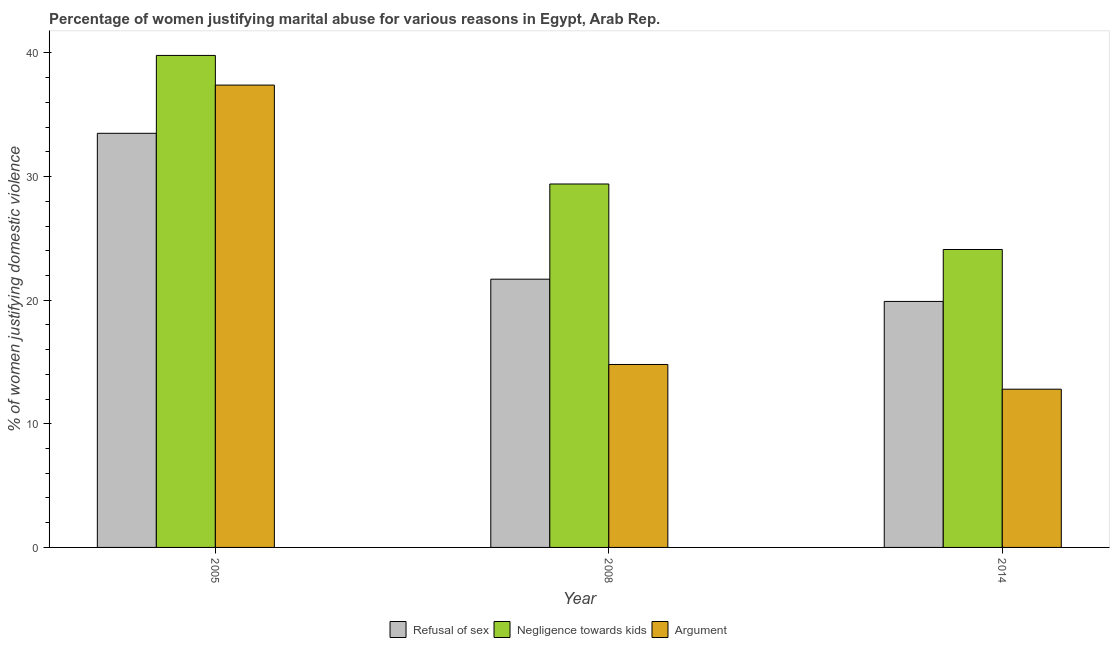How many different coloured bars are there?
Keep it short and to the point. 3. How many groups of bars are there?
Provide a short and direct response. 3. Are the number of bars on each tick of the X-axis equal?
Provide a short and direct response. Yes. What is the percentage of women justifying domestic violence due to arguments in 2005?
Your answer should be compact. 37.4. Across all years, what is the maximum percentage of women justifying domestic violence due to negligence towards kids?
Make the answer very short. 39.8. What is the total percentage of women justifying domestic violence due to arguments in the graph?
Your answer should be very brief. 65. What is the difference between the percentage of women justifying domestic violence due to negligence towards kids in 2014 and the percentage of women justifying domestic violence due to refusal of sex in 2008?
Provide a succinct answer. -5.3. What is the average percentage of women justifying domestic violence due to negligence towards kids per year?
Your response must be concise. 31.1. In how many years, is the percentage of women justifying domestic violence due to negligence towards kids greater than 34 %?
Provide a short and direct response. 1. What is the ratio of the percentage of women justifying domestic violence due to negligence towards kids in 2005 to that in 2014?
Your answer should be very brief. 1.65. Is the percentage of women justifying domestic violence due to arguments in 2008 less than that in 2014?
Ensure brevity in your answer.  No. Is the difference between the percentage of women justifying domestic violence due to arguments in 2008 and 2014 greater than the difference between the percentage of women justifying domestic violence due to refusal of sex in 2008 and 2014?
Offer a terse response. No. What is the difference between the highest and the second highest percentage of women justifying domestic violence due to arguments?
Your response must be concise. 22.6. What is the difference between the highest and the lowest percentage of women justifying domestic violence due to arguments?
Your answer should be compact. 24.6. In how many years, is the percentage of women justifying domestic violence due to refusal of sex greater than the average percentage of women justifying domestic violence due to refusal of sex taken over all years?
Ensure brevity in your answer.  1. Is the sum of the percentage of women justifying domestic violence due to arguments in 2005 and 2014 greater than the maximum percentage of women justifying domestic violence due to refusal of sex across all years?
Offer a very short reply. Yes. What does the 2nd bar from the left in 2005 represents?
Ensure brevity in your answer.  Negligence towards kids. What does the 3rd bar from the right in 2008 represents?
Keep it short and to the point. Refusal of sex. How many bars are there?
Make the answer very short. 9. Are all the bars in the graph horizontal?
Make the answer very short. No. How many years are there in the graph?
Ensure brevity in your answer.  3. Does the graph contain grids?
Provide a short and direct response. No. Where does the legend appear in the graph?
Your answer should be compact. Bottom center. How are the legend labels stacked?
Ensure brevity in your answer.  Horizontal. What is the title of the graph?
Ensure brevity in your answer.  Percentage of women justifying marital abuse for various reasons in Egypt, Arab Rep. Does "Manufactures" appear as one of the legend labels in the graph?
Offer a terse response. No. What is the label or title of the X-axis?
Your response must be concise. Year. What is the label or title of the Y-axis?
Give a very brief answer. % of women justifying domestic violence. What is the % of women justifying domestic violence of Refusal of sex in 2005?
Keep it short and to the point. 33.5. What is the % of women justifying domestic violence of Negligence towards kids in 2005?
Offer a terse response. 39.8. What is the % of women justifying domestic violence of Argument in 2005?
Make the answer very short. 37.4. What is the % of women justifying domestic violence of Refusal of sex in 2008?
Your answer should be very brief. 21.7. What is the % of women justifying domestic violence in Negligence towards kids in 2008?
Keep it short and to the point. 29.4. What is the % of women justifying domestic violence in Refusal of sex in 2014?
Offer a very short reply. 19.9. What is the % of women justifying domestic violence in Negligence towards kids in 2014?
Ensure brevity in your answer.  24.1. What is the % of women justifying domestic violence of Argument in 2014?
Ensure brevity in your answer.  12.8. Across all years, what is the maximum % of women justifying domestic violence of Refusal of sex?
Provide a short and direct response. 33.5. Across all years, what is the maximum % of women justifying domestic violence in Negligence towards kids?
Offer a very short reply. 39.8. Across all years, what is the maximum % of women justifying domestic violence in Argument?
Your answer should be very brief. 37.4. Across all years, what is the minimum % of women justifying domestic violence in Negligence towards kids?
Offer a terse response. 24.1. Across all years, what is the minimum % of women justifying domestic violence of Argument?
Provide a succinct answer. 12.8. What is the total % of women justifying domestic violence of Refusal of sex in the graph?
Give a very brief answer. 75.1. What is the total % of women justifying domestic violence of Negligence towards kids in the graph?
Provide a short and direct response. 93.3. What is the difference between the % of women justifying domestic violence in Refusal of sex in 2005 and that in 2008?
Offer a very short reply. 11.8. What is the difference between the % of women justifying domestic violence in Negligence towards kids in 2005 and that in 2008?
Your answer should be compact. 10.4. What is the difference between the % of women justifying domestic violence in Argument in 2005 and that in 2008?
Make the answer very short. 22.6. What is the difference between the % of women justifying domestic violence of Negligence towards kids in 2005 and that in 2014?
Make the answer very short. 15.7. What is the difference between the % of women justifying domestic violence of Argument in 2005 and that in 2014?
Give a very brief answer. 24.6. What is the difference between the % of women justifying domestic violence of Negligence towards kids in 2005 and the % of women justifying domestic violence of Argument in 2008?
Your answer should be very brief. 25. What is the difference between the % of women justifying domestic violence in Refusal of sex in 2005 and the % of women justifying domestic violence in Argument in 2014?
Your answer should be compact. 20.7. What is the difference between the % of women justifying domestic violence of Refusal of sex in 2008 and the % of women justifying domestic violence of Argument in 2014?
Make the answer very short. 8.9. What is the average % of women justifying domestic violence of Refusal of sex per year?
Provide a short and direct response. 25.03. What is the average % of women justifying domestic violence of Negligence towards kids per year?
Give a very brief answer. 31.1. What is the average % of women justifying domestic violence in Argument per year?
Your response must be concise. 21.67. In the year 2005, what is the difference between the % of women justifying domestic violence of Refusal of sex and % of women justifying domestic violence of Negligence towards kids?
Your answer should be compact. -6.3. In the year 2005, what is the difference between the % of women justifying domestic violence of Negligence towards kids and % of women justifying domestic violence of Argument?
Provide a succinct answer. 2.4. In the year 2008, what is the difference between the % of women justifying domestic violence in Refusal of sex and % of women justifying domestic violence in Argument?
Offer a terse response. 6.9. In the year 2008, what is the difference between the % of women justifying domestic violence in Negligence towards kids and % of women justifying domestic violence in Argument?
Ensure brevity in your answer.  14.6. In the year 2014, what is the difference between the % of women justifying domestic violence in Refusal of sex and % of women justifying domestic violence in Negligence towards kids?
Ensure brevity in your answer.  -4.2. What is the ratio of the % of women justifying domestic violence in Refusal of sex in 2005 to that in 2008?
Your answer should be very brief. 1.54. What is the ratio of the % of women justifying domestic violence of Negligence towards kids in 2005 to that in 2008?
Make the answer very short. 1.35. What is the ratio of the % of women justifying domestic violence in Argument in 2005 to that in 2008?
Ensure brevity in your answer.  2.53. What is the ratio of the % of women justifying domestic violence of Refusal of sex in 2005 to that in 2014?
Your answer should be compact. 1.68. What is the ratio of the % of women justifying domestic violence in Negligence towards kids in 2005 to that in 2014?
Provide a succinct answer. 1.65. What is the ratio of the % of women justifying domestic violence in Argument in 2005 to that in 2014?
Provide a short and direct response. 2.92. What is the ratio of the % of women justifying domestic violence of Refusal of sex in 2008 to that in 2014?
Your response must be concise. 1.09. What is the ratio of the % of women justifying domestic violence of Negligence towards kids in 2008 to that in 2014?
Make the answer very short. 1.22. What is the ratio of the % of women justifying domestic violence of Argument in 2008 to that in 2014?
Offer a very short reply. 1.16. What is the difference between the highest and the second highest % of women justifying domestic violence in Refusal of sex?
Give a very brief answer. 11.8. What is the difference between the highest and the second highest % of women justifying domestic violence in Argument?
Ensure brevity in your answer.  22.6. What is the difference between the highest and the lowest % of women justifying domestic violence of Refusal of sex?
Offer a terse response. 13.6. What is the difference between the highest and the lowest % of women justifying domestic violence of Negligence towards kids?
Offer a very short reply. 15.7. What is the difference between the highest and the lowest % of women justifying domestic violence in Argument?
Provide a short and direct response. 24.6. 